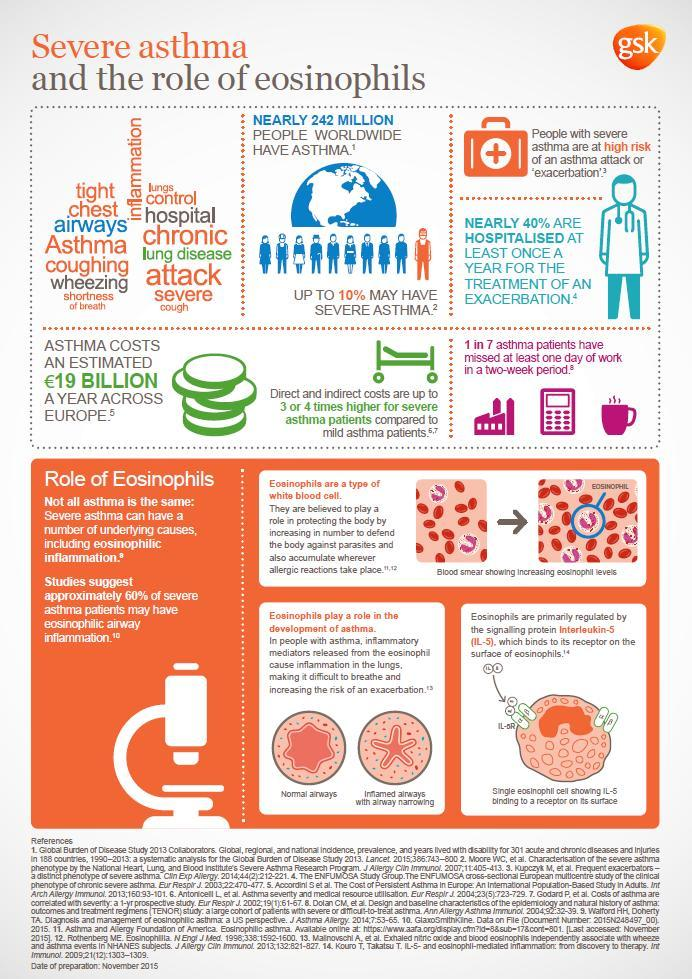What percentage of people worldwide have severe case of asthma?
Answer the question with a short phrase. 10% Which type of blood cells contributes to the development of asthma? Eosinophils What is the worldwide prevalence of asthma? Nearly 242 Million people 